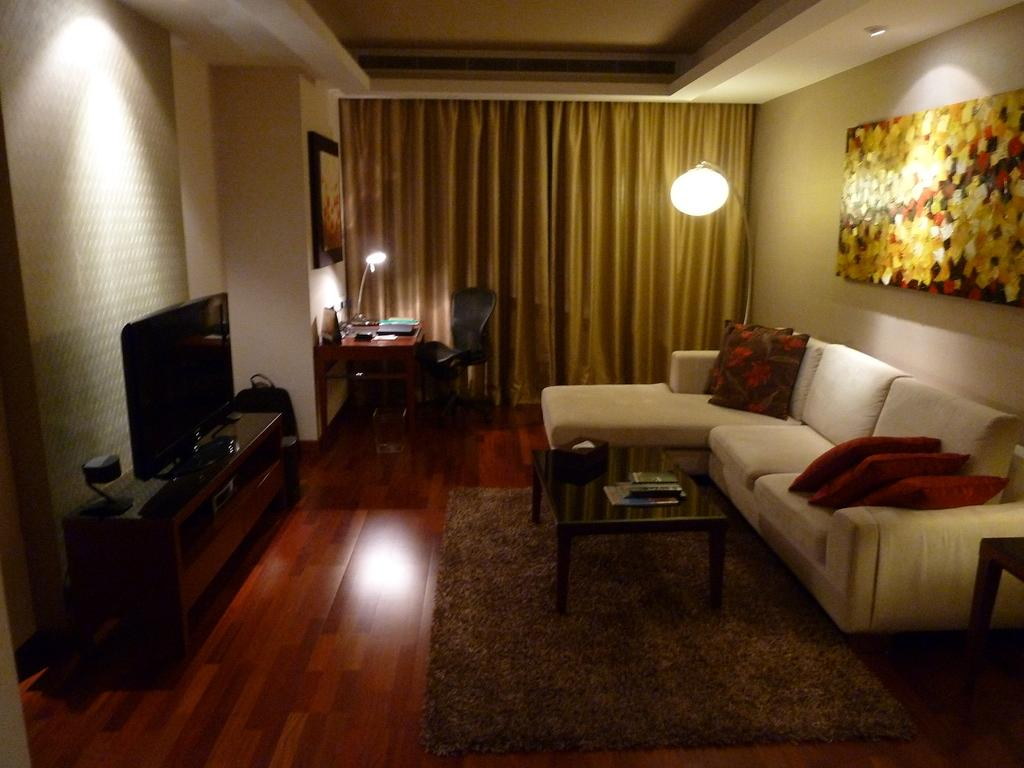What type of room is shown in the image? The image depicts a living room. What furniture is present in the living room? There is a sofa, a table on a mat, a TV on a long cupboard, and a table with a chair in the living room. How is the window in the living room covered? A curtain is used to cover the window in the living room. What type of shirt is hanging on the lumber in the living room? There is no shirt or lumber present in the living room; the image only shows a living room with furniture and a curtain. 